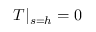<formula> <loc_0><loc_0><loc_500><loc_500>T | _ { s = h } = 0</formula> 